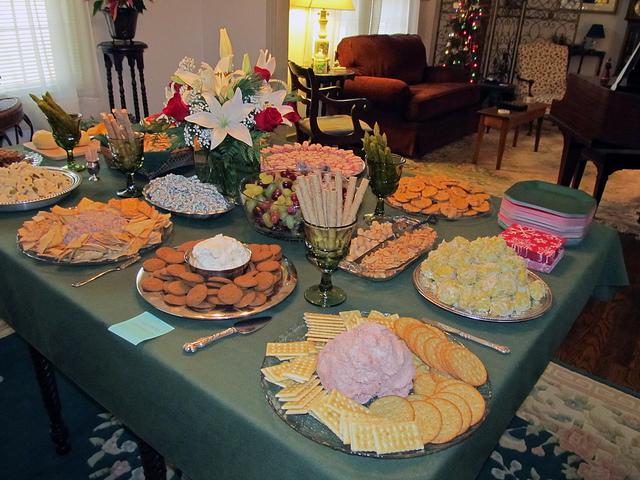Which foods are these?
Answer briefly. Appetizers. What color is the tablecloth?
Quick response, please. Green. What occasion are they celebrating?
Keep it brief. Christmas. Is there pizza on the table?
Concise answer only. No. 